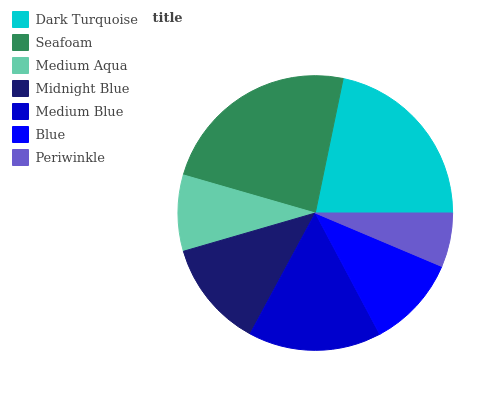Is Periwinkle the minimum?
Answer yes or no. Yes. Is Seafoam the maximum?
Answer yes or no. Yes. Is Medium Aqua the minimum?
Answer yes or no. No. Is Medium Aqua the maximum?
Answer yes or no. No. Is Seafoam greater than Medium Aqua?
Answer yes or no. Yes. Is Medium Aqua less than Seafoam?
Answer yes or no. Yes. Is Medium Aqua greater than Seafoam?
Answer yes or no. No. Is Seafoam less than Medium Aqua?
Answer yes or no. No. Is Midnight Blue the high median?
Answer yes or no. Yes. Is Midnight Blue the low median?
Answer yes or no. Yes. Is Periwinkle the high median?
Answer yes or no. No. Is Medium Aqua the low median?
Answer yes or no. No. 